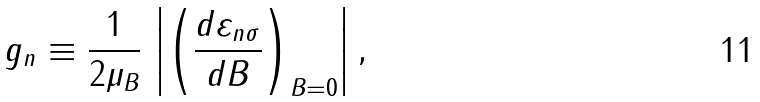Convert formula to latex. <formula><loc_0><loc_0><loc_500><loc_500>g _ { n } \equiv \frac { 1 } { 2 \mu _ { B } } \, \left | \left ( \frac { d \varepsilon _ { n \sigma } } { d B } \right ) _ { B = 0 } \right | ,</formula> 